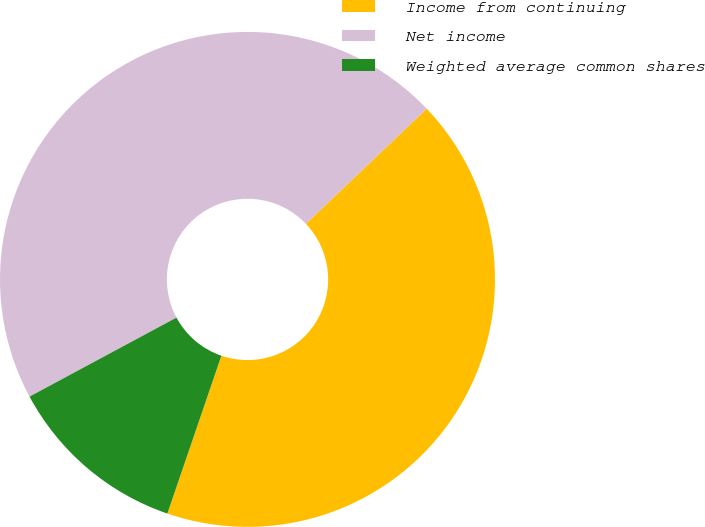Convert chart. <chart><loc_0><loc_0><loc_500><loc_500><pie_chart><fcel>Income from continuing<fcel>Net income<fcel>Weighted average common shares<nl><fcel>42.36%<fcel>45.74%<fcel>11.9%<nl></chart> 